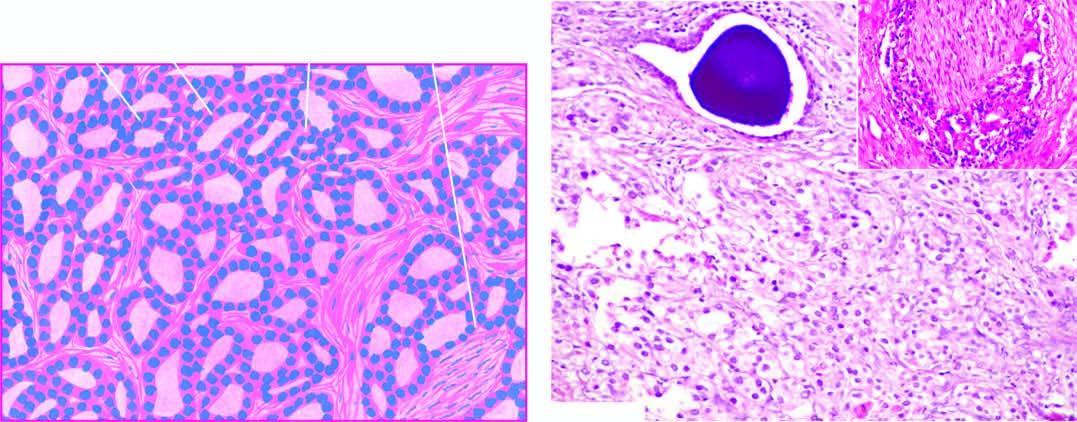how does inset in the photomicrograph show perineural invasion?
Answer the question using a single word or phrase. By prostatic adenocarcinoma 